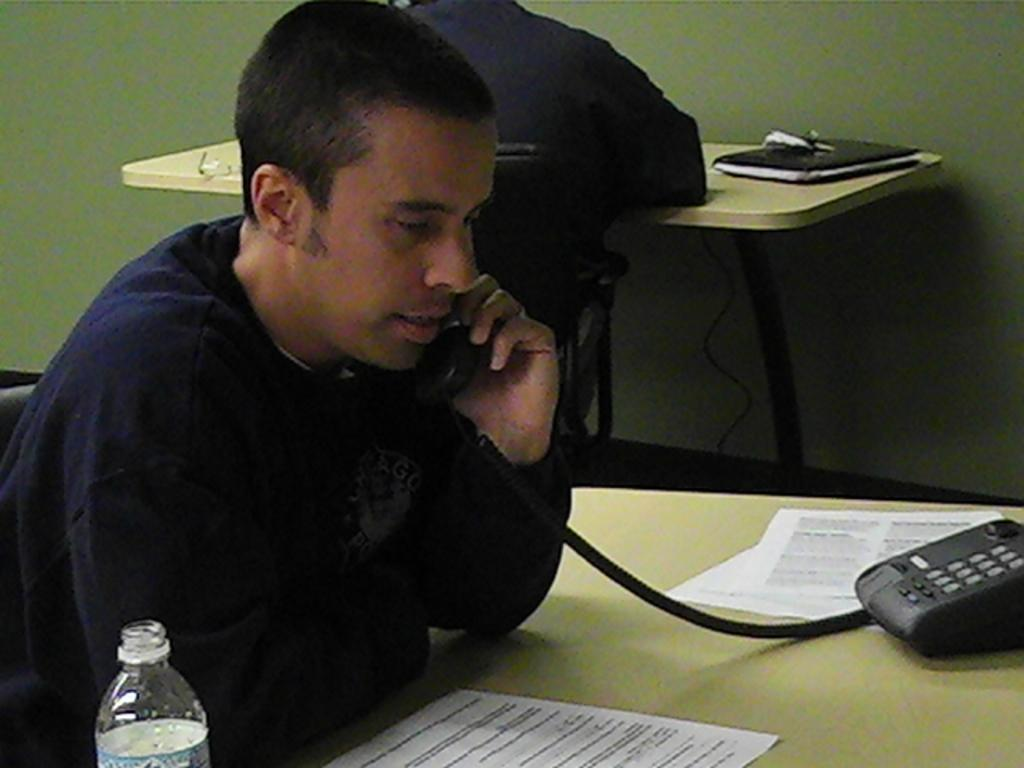What are the persons in the image doing? The persons in the image are sitting on chairs. What is one of the persons doing while sitting on a chair? One of the persons is talking on a telephone. Where is the telephone placed? The telephone is placed on a table. What type of writing material is present in the image? Stationary is present in the image. What type of container is visible in the image? There is a disposable bottle in the image. What type of electrical component is visible in the image? Cables are visible in the image. What type of ray can be seen swimming in the image? There is no ray present in the image; it features persons sitting on chairs, a telephone, a table, stationary, a disposable bottle, and cables. What type of secretary is sitting next to the person talking on the telephone? There is no secretary present in the image; it only features persons sitting on chairs, a telephone, a table, stationary, a disposable bottle, and cables. 